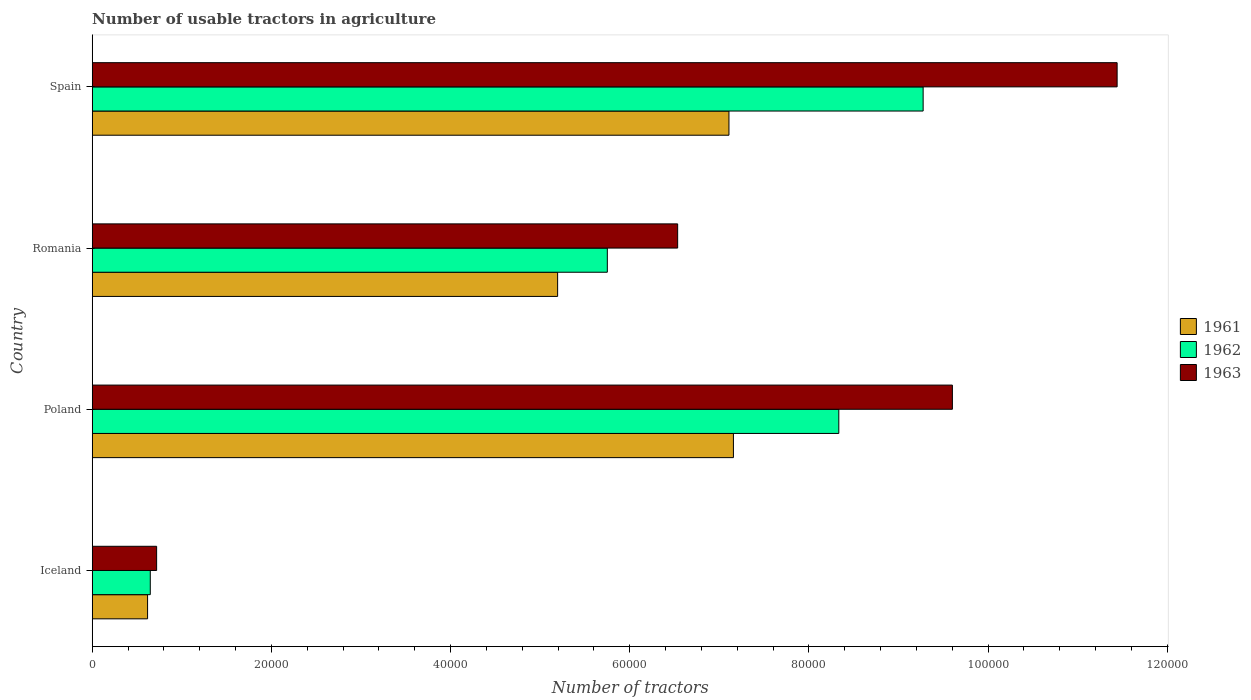How many different coloured bars are there?
Your answer should be compact. 3. How many groups of bars are there?
Keep it short and to the point. 4. Are the number of bars on each tick of the Y-axis equal?
Your answer should be compact. Yes. How many bars are there on the 1st tick from the top?
Your response must be concise. 3. How many bars are there on the 4th tick from the bottom?
Offer a terse response. 3. What is the number of usable tractors in agriculture in 1962 in Iceland?
Offer a terse response. 6479. Across all countries, what is the maximum number of usable tractors in agriculture in 1962?
Your answer should be compact. 9.28e+04. Across all countries, what is the minimum number of usable tractors in agriculture in 1963?
Provide a succinct answer. 7187. In which country was the number of usable tractors in agriculture in 1962 maximum?
Make the answer very short. Spain. In which country was the number of usable tractors in agriculture in 1961 minimum?
Your answer should be compact. Iceland. What is the total number of usable tractors in agriculture in 1963 in the graph?
Ensure brevity in your answer.  2.83e+05. What is the difference between the number of usable tractors in agriculture in 1963 in Iceland and that in Poland?
Provide a short and direct response. -8.88e+04. What is the difference between the number of usable tractors in agriculture in 1962 in Romania and the number of usable tractors in agriculture in 1961 in Spain?
Provide a short and direct response. -1.36e+04. What is the average number of usable tractors in agriculture in 1961 per country?
Ensure brevity in your answer.  5.02e+04. What is the difference between the number of usable tractors in agriculture in 1961 and number of usable tractors in agriculture in 1962 in Spain?
Your response must be concise. -2.17e+04. What is the ratio of the number of usable tractors in agriculture in 1961 in Iceland to that in Romania?
Give a very brief answer. 0.12. Is the number of usable tractors in agriculture in 1963 in Iceland less than that in Poland?
Offer a very short reply. Yes. Is the difference between the number of usable tractors in agriculture in 1961 in Poland and Spain greater than the difference between the number of usable tractors in agriculture in 1962 in Poland and Spain?
Give a very brief answer. Yes. What is the difference between the highest and the second highest number of usable tractors in agriculture in 1962?
Offer a very short reply. 9414. What is the difference between the highest and the lowest number of usable tractors in agriculture in 1961?
Offer a very short reply. 6.54e+04. How many bars are there?
Ensure brevity in your answer.  12. Are all the bars in the graph horizontal?
Provide a succinct answer. Yes. Are the values on the major ticks of X-axis written in scientific E-notation?
Give a very brief answer. No. Does the graph contain any zero values?
Your response must be concise. No. How many legend labels are there?
Make the answer very short. 3. How are the legend labels stacked?
Offer a terse response. Vertical. What is the title of the graph?
Your answer should be compact. Number of usable tractors in agriculture. What is the label or title of the X-axis?
Make the answer very short. Number of tractors. What is the label or title of the Y-axis?
Ensure brevity in your answer.  Country. What is the Number of tractors in 1961 in Iceland?
Your answer should be compact. 6177. What is the Number of tractors of 1962 in Iceland?
Offer a very short reply. 6479. What is the Number of tractors of 1963 in Iceland?
Provide a short and direct response. 7187. What is the Number of tractors in 1961 in Poland?
Provide a short and direct response. 7.16e+04. What is the Number of tractors of 1962 in Poland?
Give a very brief answer. 8.33e+04. What is the Number of tractors of 1963 in Poland?
Your answer should be very brief. 9.60e+04. What is the Number of tractors of 1961 in Romania?
Offer a terse response. 5.20e+04. What is the Number of tractors in 1962 in Romania?
Offer a terse response. 5.75e+04. What is the Number of tractors of 1963 in Romania?
Offer a terse response. 6.54e+04. What is the Number of tractors of 1961 in Spain?
Provide a short and direct response. 7.11e+04. What is the Number of tractors in 1962 in Spain?
Your answer should be very brief. 9.28e+04. What is the Number of tractors of 1963 in Spain?
Your response must be concise. 1.14e+05. Across all countries, what is the maximum Number of tractors in 1961?
Your response must be concise. 7.16e+04. Across all countries, what is the maximum Number of tractors in 1962?
Give a very brief answer. 9.28e+04. Across all countries, what is the maximum Number of tractors of 1963?
Offer a terse response. 1.14e+05. Across all countries, what is the minimum Number of tractors in 1961?
Make the answer very short. 6177. Across all countries, what is the minimum Number of tractors of 1962?
Ensure brevity in your answer.  6479. Across all countries, what is the minimum Number of tractors in 1963?
Provide a short and direct response. 7187. What is the total Number of tractors of 1961 in the graph?
Offer a terse response. 2.01e+05. What is the total Number of tractors in 1962 in the graph?
Give a very brief answer. 2.40e+05. What is the total Number of tractors of 1963 in the graph?
Offer a terse response. 2.83e+05. What is the difference between the Number of tractors in 1961 in Iceland and that in Poland?
Give a very brief answer. -6.54e+04. What is the difference between the Number of tractors in 1962 in Iceland and that in Poland?
Your answer should be compact. -7.69e+04. What is the difference between the Number of tractors in 1963 in Iceland and that in Poland?
Ensure brevity in your answer.  -8.88e+04. What is the difference between the Number of tractors of 1961 in Iceland and that in Romania?
Make the answer very short. -4.58e+04. What is the difference between the Number of tractors in 1962 in Iceland and that in Romania?
Keep it short and to the point. -5.10e+04. What is the difference between the Number of tractors of 1963 in Iceland and that in Romania?
Offer a very short reply. -5.82e+04. What is the difference between the Number of tractors of 1961 in Iceland and that in Spain?
Your answer should be compact. -6.49e+04. What is the difference between the Number of tractors in 1962 in Iceland and that in Spain?
Provide a succinct answer. -8.63e+04. What is the difference between the Number of tractors of 1963 in Iceland and that in Spain?
Make the answer very short. -1.07e+05. What is the difference between the Number of tractors in 1961 in Poland and that in Romania?
Your answer should be compact. 1.96e+04. What is the difference between the Number of tractors of 1962 in Poland and that in Romania?
Offer a terse response. 2.58e+04. What is the difference between the Number of tractors of 1963 in Poland and that in Romania?
Your answer should be very brief. 3.07e+04. What is the difference between the Number of tractors in 1962 in Poland and that in Spain?
Make the answer very short. -9414. What is the difference between the Number of tractors in 1963 in Poland and that in Spain?
Your response must be concise. -1.84e+04. What is the difference between the Number of tractors of 1961 in Romania and that in Spain?
Your response must be concise. -1.91e+04. What is the difference between the Number of tractors of 1962 in Romania and that in Spain?
Offer a very short reply. -3.53e+04. What is the difference between the Number of tractors of 1963 in Romania and that in Spain?
Your answer should be very brief. -4.91e+04. What is the difference between the Number of tractors in 1961 in Iceland and the Number of tractors in 1962 in Poland?
Your answer should be very brief. -7.72e+04. What is the difference between the Number of tractors of 1961 in Iceland and the Number of tractors of 1963 in Poland?
Make the answer very short. -8.98e+04. What is the difference between the Number of tractors of 1962 in Iceland and the Number of tractors of 1963 in Poland?
Ensure brevity in your answer.  -8.95e+04. What is the difference between the Number of tractors of 1961 in Iceland and the Number of tractors of 1962 in Romania?
Offer a very short reply. -5.13e+04. What is the difference between the Number of tractors in 1961 in Iceland and the Number of tractors in 1963 in Romania?
Offer a very short reply. -5.92e+04. What is the difference between the Number of tractors of 1962 in Iceland and the Number of tractors of 1963 in Romania?
Keep it short and to the point. -5.89e+04. What is the difference between the Number of tractors in 1961 in Iceland and the Number of tractors in 1962 in Spain?
Your answer should be very brief. -8.66e+04. What is the difference between the Number of tractors of 1961 in Iceland and the Number of tractors of 1963 in Spain?
Ensure brevity in your answer.  -1.08e+05. What is the difference between the Number of tractors in 1962 in Iceland and the Number of tractors in 1963 in Spain?
Your answer should be very brief. -1.08e+05. What is the difference between the Number of tractors in 1961 in Poland and the Number of tractors in 1962 in Romania?
Provide a succinct answer. 1.41e+04. What is the difference between the Number of tractors in 1961 in Poland and the Number of tractors in 1963 in Romania?
Give a very brief answer. 6226. What is the difference between the Number of tractors in 1962 in Poland and the Number of tractors in 1963 in Romania?
Your response must be concise. 1.80e+04. What is the difference between the Number of tractors in 1961 in Poland and the Number of tractors in 1962 in Spain?
Offer a terse response. -2.12e+04. What is the difference between the Number of tractors in 1961 in Poland and the Number of tractors in 1963 in Spain?
Keep it short and to the point. -4.28e+04. What is the difference between the Number of tractors of 1962 in Poland and the Number of tractors of 1963 in Spain?
Offer a terse response. -3.11e+04. What is the difference between the Number of tractors of 1961 in Romania and the Number of tractors of 1962 in Spain?
Your response must be concise. -4.08e+04. What is the difference between the Number of tractors in 1961 in Romania and the Number of tractors in 1963 in Spain?
Make the answer very short. -6.25e+04. What is the difference between the Number of tractors of 1962 in Romania and the Number of tractors of 1963 in Spain?
Provide a succinct answer. -5.69e+04. What is the average Number of tractors in 1961 per country?
Your answer should be compact. 5.02e+04. What is the average Number of tractors of 1962 per country?
Your answer should be compact. 6.00e+04. What is the average Number of tractors in 1963 per country?
Offer a terse response. 7.07e+04. What is the difference between the Number of tractors in 1961 and Number of tractors in 1962 in Iceland?
Ensure brevity in your answer.  -302. What is the difference between the Number of tractors in 1961 and Number of tractors in 1963 in Iceland?
Ensure brevity in your answer.  -1010. What is the difference between the Number of tractors of 1962 and Number of tractors of 1963 in Iceland?
Offer a terse response. -708. What is the difference between the Number of tractors of 1961 and Number of tractors of 1962 in Poland?
Offer a very short reply. -1.18e+04. What is the difference between the Number of tractors in 1961 and Number of tractors in 1963 in Poland?
Ensure brevity in your answer.  -2.44e+04. What is the difference between the Number of tractors in 1962 and Number of tractors in 1963 in Poland?
Your answer should be compact. -1.27e+04. What is the difference between the Number of tractors of 1961 and Number of tractors of 1962 in Romania?
Make the answer very short. -5548. What is the difference between the Number of tractors in 1961 and Number of tractors in 1963 in Romania?
Offer a very short reply. -1.34e+04. What is the difference between the Number of tractors of 1962 and Number of tractors of 1963 in Romania?
Ensure brevity in your answer.  -7851. What is the difference between the Number of tractors of 1961 and Number of tractors of 1962 in Spain?
Your answer should be very brief. -2.17e+04. What is the difference between the Number of tractors in 1961 and Number of tractors in 1963 in Spain?
Give a very brief answer. -4.33e+04. What is the difference between the Number of tractors in 1962 and Number of tractors in 1963 in Spain?
Offer a terse response. -2.17e+04. What is the ratio of the Number of tractors of 1961 in Iceland to that in Poland?
Make the answer very short. 0.09. What is the ratio of the Number of tractors of 1962 in Iceland to that in Poland?
Make the answer very short. 0.08. What is the ratio of the Number of tractors in 1963 in Iceland to that in Poland?
Keep it short and to the point. 0.07. What is the ratio of the Number of tractors of 1961 in Iceland to that in Romania?
Keep it short and to the point. 0.12. What is the ratio of the Number of tractors in 1962 in Iceland to that in Romania?
Make the answer very short. 0.11. What is the ratio of the Number of tractors of 1963 in Iceland to that in Romania?
Your answer should be very brief. 0.11. What is the ratio of the Number of tractors in 1961 in Iceland to that in Spain?
Your answer should be very brief. 0.09. What is the ratio of the Number of tractors of 1962 in Iceland to that in Spain?
Ensure brevity in your answer.  0.07. What is the ratio of the Number of tractors of 1963 in Iceland to that in Spain?
Offer a very short reply. 0.06. What is the ratio of the Number of tractors in 1961 in Poland to that in Romania?
Your answer should be compact. 1.38. What is the ratio of the Number of tractors in 1962 in Poland to that in Romania?
Your answer should be very brief. 1.45. What is the ratio of the Number of tractors of 1963 in Poland to that in Romania?
Keep it short and to the point. 1.47. What is the ratio of the Number of tractors of 1962 in Poland to that in Spain?
Your answer should be very brief. 0.9. What is the ratio of the Number of tractors in 1963 in Poland to that in Spain?
Your response must be concise. 0.84. What is the ratio of the Number of tractors in 1961 in Romania to that in Spain?
Make the answer very short. 0.73. What is the ratio of the Number of tractors in 1962 in Romania to that in Spain?
Keep it short and to the point. 0.62. What is the ratio of the Number of tractors of 1963 in Romania to that in Spain?
Provide a short and direct response. 0.57. What is the difference between the highest and the second highest Number of tractors in 1961?
Your answer should be compact. 500. What is the difference between the highest and the second highest Number of tractors in 1962?
Offer a very short reply. 9414. What is the difference between the highest and the second highest Number of tractors in 1963?
Your answer should be very brief. 1.84e+04. What is the difference between the highest and the lowest Number of tractors of 1961?
Your response must be concise. 6.54e+04. What is the difference between the highest and the lowest Number of tractors in 1962?
Keep it short and to the point. 8.63e+04. What is the difference between the highest and the lowest Number of tractors in 1963?
Provide a succinct answer. 1.07e+05. 